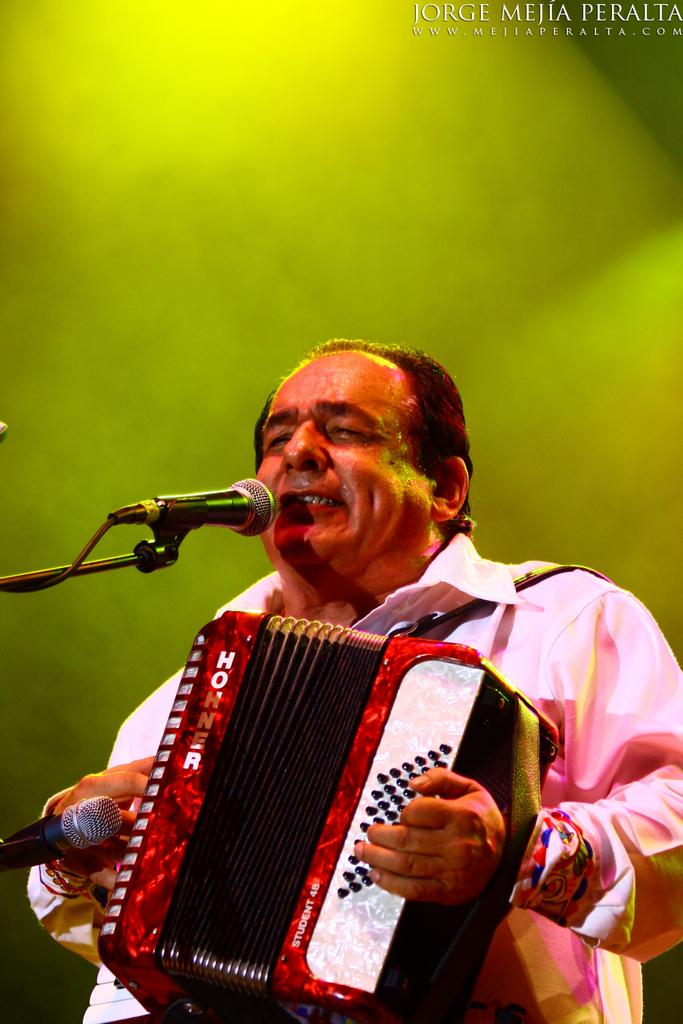What is the main subject of the image? The main subject of the image is a man. What is the man holding in the image? The man is holding a musical instrument. What can be seen behind the man? The man is standing in front of microphones. What color is the background of the image? The background of the image is green. What is located in the top right corner of the image? There is text in the top right corner of the image. Can you describe the queen's reaction to the rainstorm in the image? There is no queen or rainstorm present in the image; it features a man holding a musical instrument in front of microphones. 